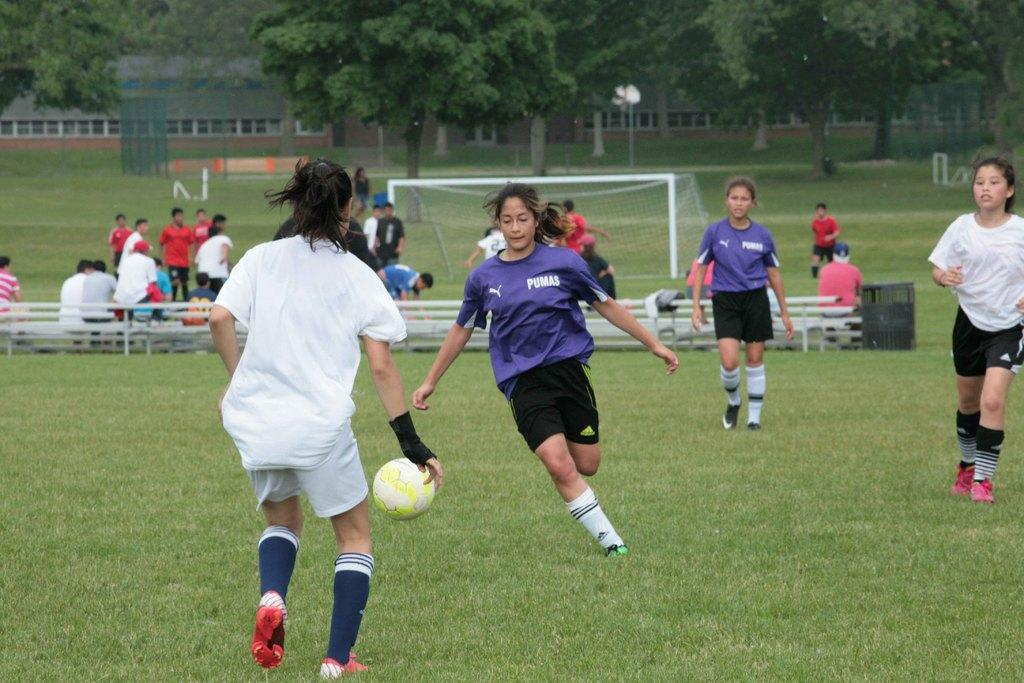Provide a one-sentence caption for the provided image. A woman in a Pumas shirt goes for the soccer ball with her arms out to her sides. 